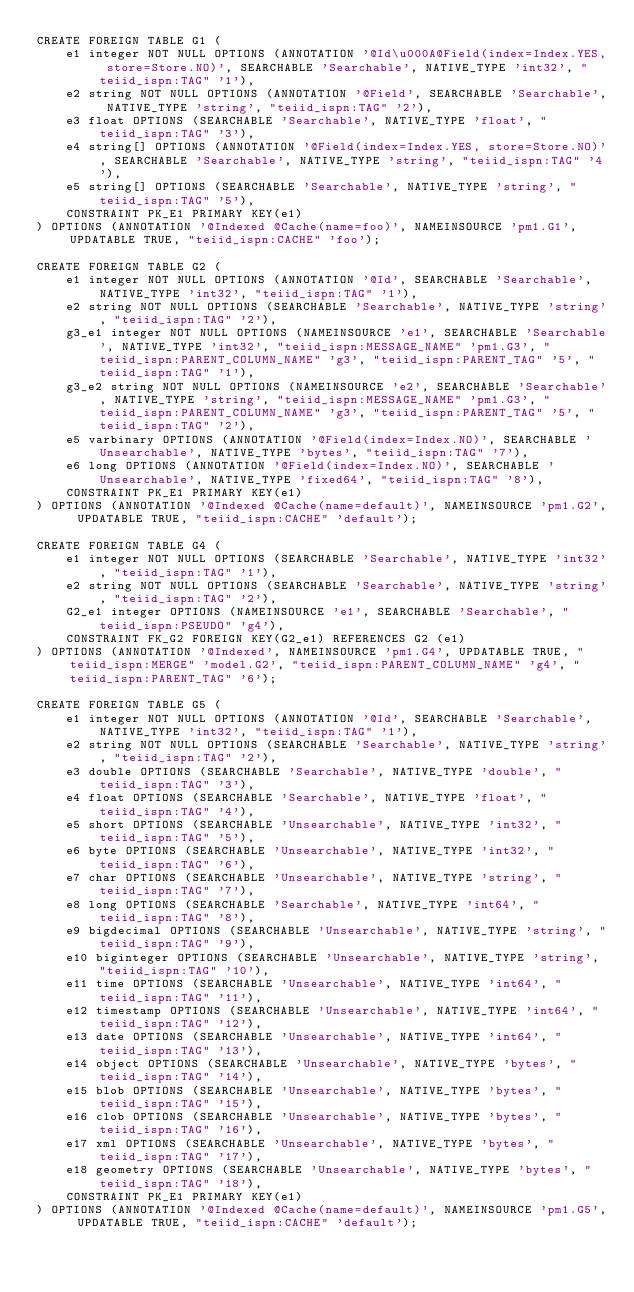Convert code to text. <code><loc_0><loc_0><loc_500><loc_500><_SQL_>CREATE FOREIGN TABLE G1 (
	e1 integer NOT NULL OPTIONS (ANNOTATION '@Id\u000A@Field(index=Index.YES, store=Store.NO)', SEARCHABLE 'Searchable', NATIVE_TYPE 'int32', "teiid_ispn:TAG" '1'),
	e2 string NOT NULL OPTIONS (ANNOTATION '@Field', SEARCHABLE 'Searchable', NATIVE_TYPE 'string', "teiid_ispn:TAG" '2'),
	e3 float OPTIONS (SEARCHABLE 'Searchable', NATIVE_TYPE 'float', "teiid_ispn:TAG" '3'),
	e4 string[] OPTIONS (ANNOTATION '@Field(index=Index.YES, store=Store.NO)', SEARCHABLE 'Searchable', NATIVE_TYPE 'string', "teiid_ispn:TAG" '4'),
	e5 string[] OPTIONS (SEARCHABLE 'Searchable', NATIVE_TYPE 'string', "teiid_ispn:TAG" '5'),
	CONSTRAINT PK_E1 PRIMARY KEY(e1)
) OPTIONS (ANNOTATION '@Indexed @Cache(name=foo)', NAMEINSOURCE 'pm1.G1', UPDATABLE TRUE, "teiid_ispn:CACHE" 'foo');

CREATE FOREIGN TABLE G2 (
	e1 integer NOT NULL OPTIONS (ANNOTATION '@Id', SEARCHABLE 'Searchable', NATIVE_TYPE 'int32', "teiid_ispn:TAG" '1'),
	e2 string NOT NULL OPTIONS (SEARCHABLE 'Searchable', NATIVE_TYPE 'string', "teiid_ispn:TAG" '2'),
	g3_e1 integer NOT NULL OPTIONS (NAMEINSOURCE 'e1', SEARCHABLE 'Searchable', NATIVE_TYPE 'int32', "teiid_ispn:MESSAGE_NAME" 'pm1.G3', "teiid_ispn:PARENT_COLUMN_NAME" 'g3', "teiid_ispn:PARENT_TAG" '5', "teiid_ispn:TAG" '1'),
	g3_e2 string NOT NULL OPTIONS (NAMEINSOURCE 'e2', SEARCHABLE 'Searchable', NATIVE_TYPE 'string', "teiid_ispn:MESSAGE_NAME" 'pm1.G3', "teiid_ispn:PARENT_COLUMN_NAME" 'g3', "teiid_ispn:PARENT_TAG" '5', "teiid_ispn:TAG" '2'),
	e5 varbinary OPTIONS (ANNOTATION '@Field(index=Index.NO)', SEARCHABLE 'Unsearchable', NATIVE_TYPE 'bytes', "teiid_ispn:TAG" '7'),
	e6 long OPTIONS (ANNOTATION '@Field(index=Index.NO)', SEARCHABLE 'Unsearchable', NATIVE_TYPE 'fixed64', "teiid_ispn:TAG" '8'),
	CONSTRAINT PK_E1 PRIMARY KEY(e1)
) OPTIONS (ANNOTATION '@Indexed @Cache(name=default)', NAMEINSOURCE 'pm1.G2', UPDATABLE TRUE, "teiid_ispn:CACHE" 'default');

CREATE FOREIGN TABLE G4 (
	e1 integer NOT NULL OPTIONS (SEARCHABLE 'Searchable', NATIVE_TYPE 'int32', "teiid_ispn:TAG" '1'),
	e2 string NOT NULL OPTIONS (SEARCHABLE 'Searchable', NATIVE_TYPE 'string', "teiid_ispn:TAG" '2'),
	G2_e1 integer OPTIONS (NAMEINSOURCE 'e1', SEARCHABLE 'Searchable', "teiid_ispn:PSEUDO" 'g4'),
	CONSTRAINT FK_G2 FOREIGN KEY(G2_e1) REFERENCES G2 (e1)
) OPTIONS (ANNOTATION '@Indexed', NAMEINSOURCE 'pm1.G4', UPDATABLE TRUE, "teiid_ispn:MERGE" 'model.G2', "teiid_ispn:PARENT_COLUMN_NAME" 'g4', "teiid_ispn:PARENT_TAG" '6');

CREATE FOREIGN TABLE G5 (
	e1 integer NOT NULL OPTIONS (ANNOTATION '@Id', SEARCHABLE 'Searchable', NATIVE_TYPE 'int32', "teiid_ispn:TAG" '1'),
	e2 string NOT NULL OPTIONS (SEARCHABLE 'Searchable', NATIVE_TYPE 'string', "teiid_ispn:TAG" '2'),
	e3 double OPTIONS (SEARCHABLE 'Searchable', NATIVE_TYPE 'double', "teiid_ispn:TAG" '3'),
	e4 float OPTIONS (SEARCHABLE 'Searchable', NATIVE_TYPE 'float', "teiid_ispn:TAG" '4'),
	e5 short OPTIONS (SEARCHABLE 'Unsearchable', NATIVE_TYPE 'int32', "teiid_ispn:TAG" '5'),
	e6 byte OPTIONS (SEARCHABLE 'Unsearchable', NATIVE_TYPE 'int32', "teiid_ispn:TAG" '6'),
	e7 char OPTIONS (SEARCHABLE 'Unsearchable', NATIVE_TYPE 'string', "teiid_ispn:TAG" '7'),
	e8 long OPTIONS (SEARCHABLE 'Searchable', NATIVE_TYPE 'int64', "teiid_ispn:TAG" '8'),
	e9 bigdecimal OPTIONS (SEARCHABLE 'Unsearchable', NATIVE_TYPE 'string', "teiid_ispn:TAG" '9'),
	e10 biginteger OPTIONS (SEARCHABLE 'Unsearchable', NATIVE_TYPE 'string', "teiid_ispn:TAG" '10'),
	e11 time OPTIONS (SEARCHABLE 'Unsearchable', NATIVE_TYPE 'int64', "teiid_ispn:TAG" '11'),
	e12 timestamp OPTIONS (SEARCHABLE 'Unsearchable', NATIVE_TYPE 'int64', "teiid_ispn:TAG" '12'),
	e13 date OPTIONS (SEARCHABLE 'Unsearchable', NATIVE_TYPE 'int64', "teiid_ispn:TAG" '13'),
	e14 object OPTIONS (SEARCHABLE 'Unsearchable', NATIVE_TYPE 'bytes', "teiid_ispn:TAG" '14'),
	e15 blob OPTIONS (SEARCHABLE 'Unsearchable', NATIVE_TYPE 'bytes', "teiid_ispn:TAG" '15'),
	e16 clob OPTIONS (SEARCHABLE 'Unsearchable', NATIVE_TYPE 'bytes', "teiid_ispn:TAG" '16'),
	e17 xml OPTIONS (SEARCHABLE 'Unsearchable', NATIVE_TYPE 'bytes', "teiid_ispn:TAG" '17'),
	e18 geometry OPTIONS (SEARCHABLE 'Unsearchable', NATIVE_TYPE 'bytes', "teiid_ispn:TAG" '18'),
	CONSTRAINT PK_E1 PRIMARY KEY(e1)
) OPTIONS (ANNOTATION '@Indexed @Cache(name=default)', NAMEINSOURCE 'pm1.G5', UPDATABLE TRUE, "teiid_ispn:CACHE" 'default');</code> 